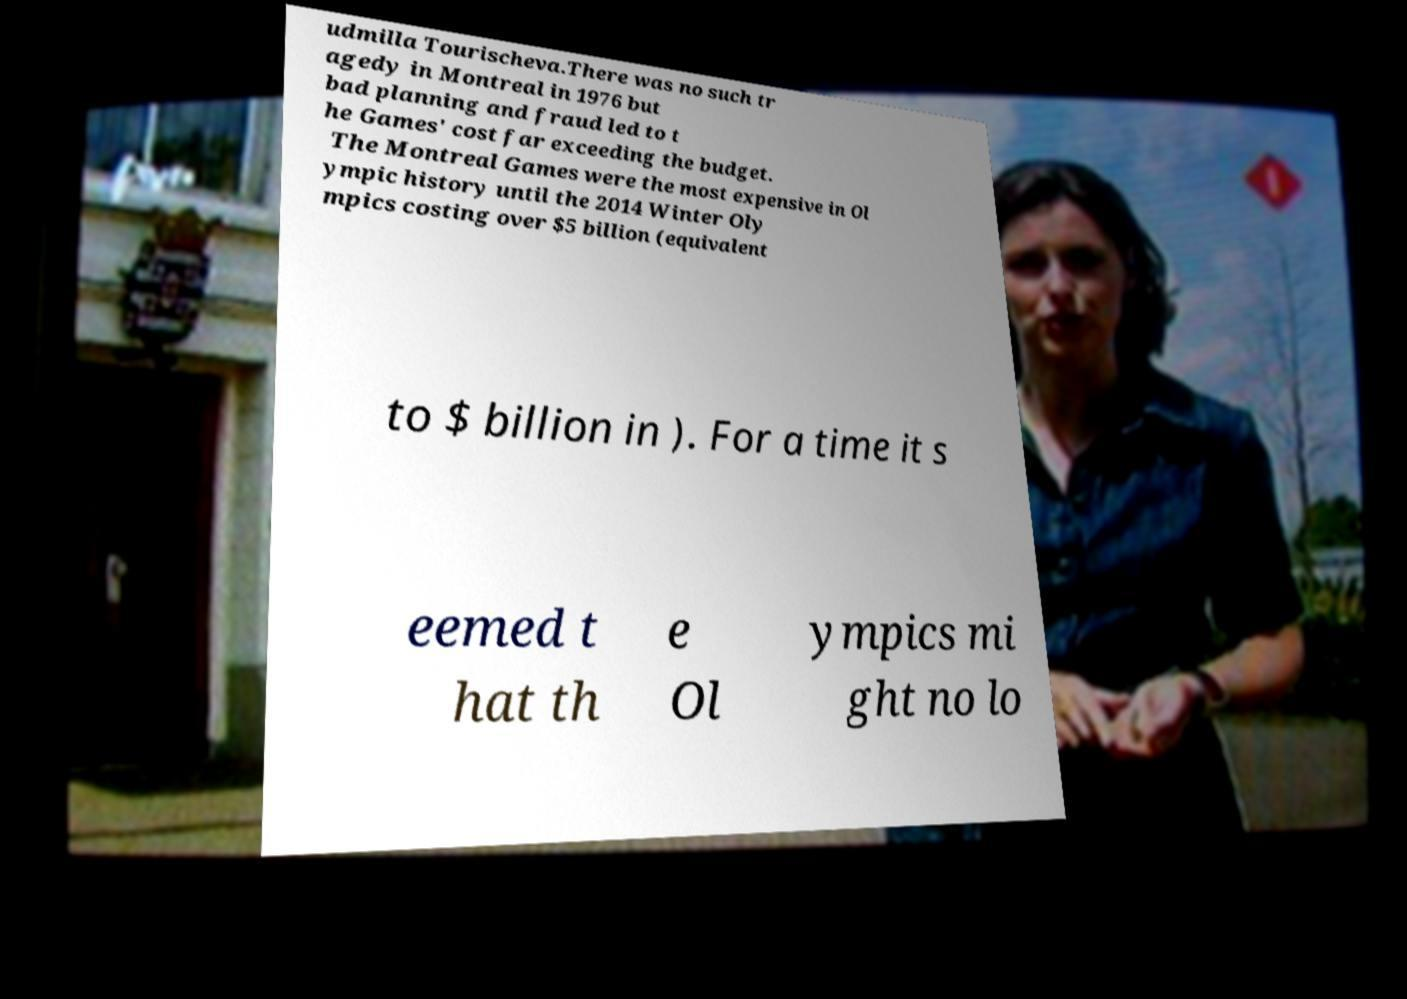Could you assist in decoding the text presented in this image and type it out clearly? udmilla Tourischeva.There was no such tr agedy in Montreal in 1976 but bad planning and fraud led to t he Games' cost far exceeding the budget. The Montreal Games were the most expensive in Ol ympic history until the 2014 Winter Oly mpics costing over $5 billion (equivalent to $ billion in ). For a time it s eemed t hat th e Ol ympics mi ght no lo 